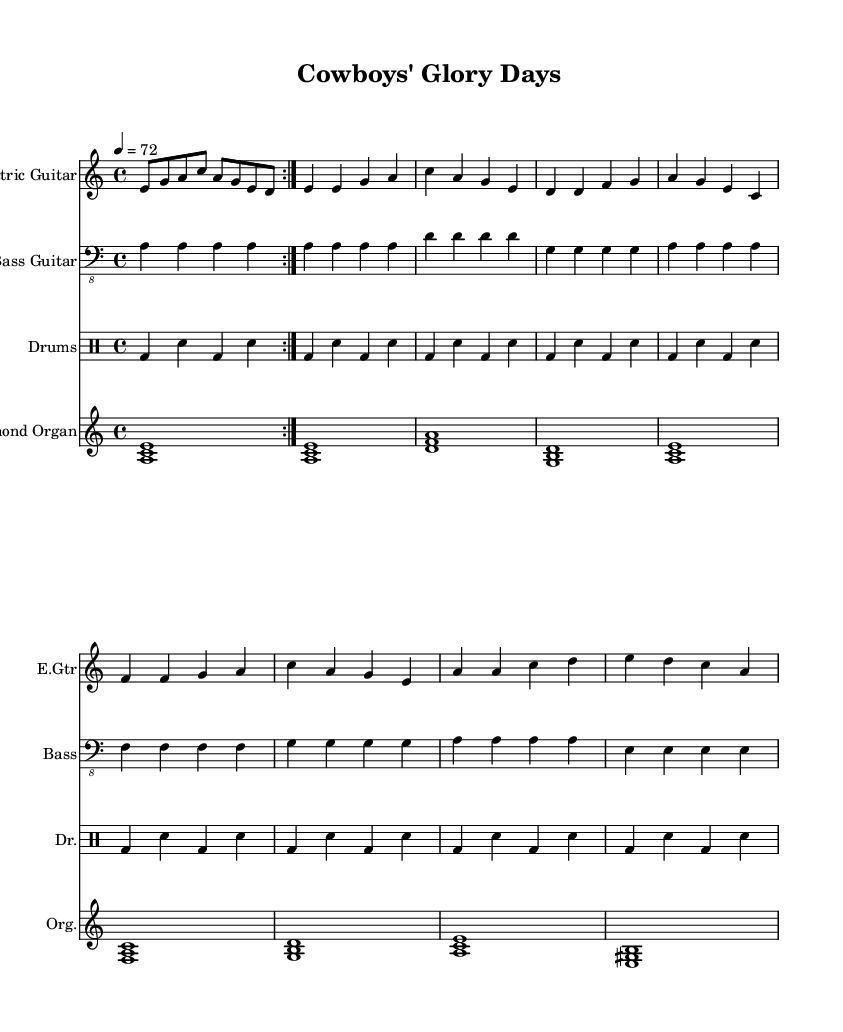What is the key signature of this music? The key signature is A minor, which has no sharps or flats, indicated by the 'a' noted in the key signature section.
Answer: A minor What is the time signature of this music? The time signature is 4/4, which means there are four beats in a measure, and a quarter note gets one beat, as shown in the time signature section of the sheet music.
Answer: 4/4 What is the tempo of this piece? The tempo is 72 beats per minute, and this is indicated above the score where it states '4 = 72', meaning that one quarter note equals 72 beats in one minute.
Answer: 72 How many times is the electric guitar part repeated? The electric guitar part is repeated 2 times, as specified by the 'repeat volta 2' notation, indicating to go through that section twice.
Answer: 2 Which instrument has the longest note value in the music sheet? The Hammond Organ is the only instrument playing whole notes (indicated by the '1' after the chords, meaning they are held for the whole measure), making it the instrument with the longest note values in the score.
Answer: Hammond Organ What section does the bass guitar play the note 'D'? The bass guitar plays the note 'D' in the second measure of the repeated section, confirming its presence with the bass clef indicating the pitch of notes in that region.
Answer: Second measure What style of music is represented in the sheet music? The music represents Electric Blues, characterized by the use of electric guitar and its bluesy elements combined with rock rhythms, as is inherent in the chord progressions and instrumentation shown.
Answer: Electric Blues 